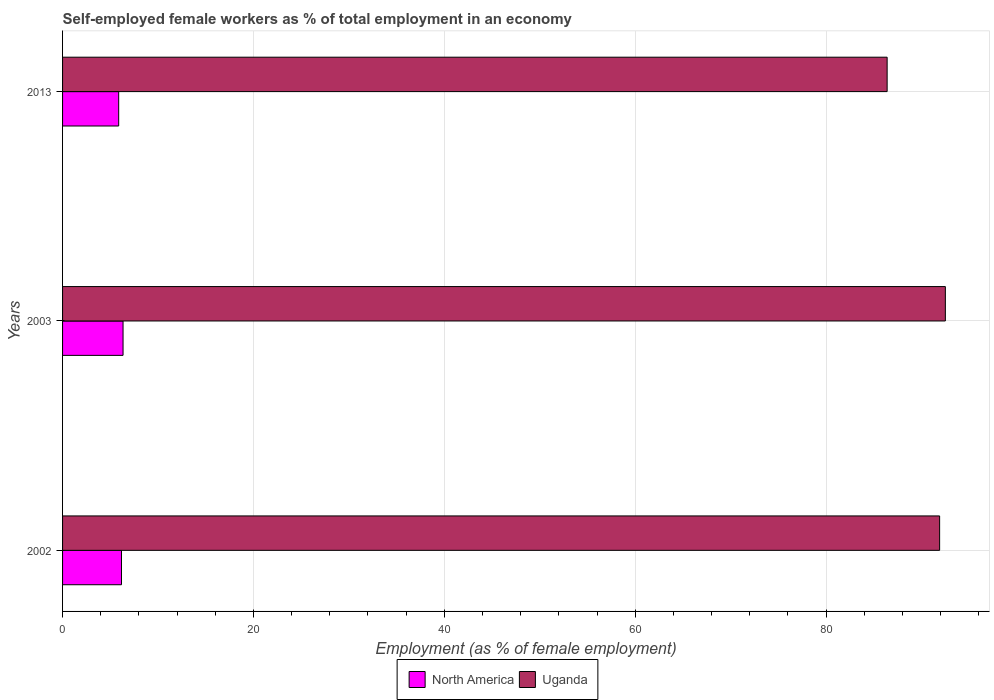Are the number of bars per tick equal to the number of legend labels?
Keep it short and to the point. Yes. How many bars are there on the 3rd tick from the top?
Your answer should be very brief. 2. How many bars are there on the 3rd tick from the bottom?
Your answer should be very brief. 2. What is the label of the 1st group of bars from the top?
Ensure brevity in your answer.  2013. What is the percentage of self-employed female workers in North America in 2002?
Make the answer very short. 6.17. Across all years, what is the maximum percentage of self-employed female workers in North America?
Give a very brief answer. 6.34. Across all years, what is the minimum percentage of self-employed female workers in North America?
Your answer should be very brief. 5.88. What is the total percentage of self-employed female workers in Uganda in the graph?
Provide a short and direct response. 270.8. What is the difference between the percentage of self-employed female workers in North America in 2003 and that in 2013?
Give a very brief answer. 0.46. What is the difference between the percentage of self-employed female workers in North America in 2013 and the percentage of self-employed female workers in Uganda in 2002?
Offer a very short reply. -86.02. What is the average percentage of self-employed female workers in North America per year?
Provide a succinct answer. 6.13. In the year 2002, what is the difference between the percentage of self-employed female workers in North America and percentage of self-employed female workers in Uganda?
Give a very brief answer. -85.73. In how many years, is the percentage of self-employed female workers in North America greater than 40 %?
Your response must be concise. 0. What is the ratio of the percentage of self-employed female workers in North America in 2003 to that in 2013?
Keep it short and to the point. 1.08. Is the difference between the percentage of self-employed female workers in North America in 2002 and 2003 greater than the difference between the percentage of self-employed female workers in Uganda in 2002 and 2003?
Your answer should be compact. Yes. What is the difference between the highest and the second highest percentage of self-employed female workers in North America?
Your response must be concise. 0.16. What is the difference between the highest and the lowest percentage of self-employed female workers in North America?
Keep it short and to the point. 0.46. In how many years, is the percentage of self-employed female workers in North America greater than the average percentage of self-employed female workers in North America taken over all years?
Offer a very short reply. 2. What does the 1st bar from the top in 2002 represents?
Your answer should be very brief. Uganda. What does the 2nd bar from the bottom in 2013 represents?
Give a very brief answer. Uganda. Are all the bars in the graph horizontal?
Provide a succinct answer. Yes. Does the graph contain grids?
Make the answer very short. Yes. How many legend labels are there?
Make the answer very short. 2. How are the legend labels stacked?
Provide a succinct answer. Horizontal. What is the title of the graph?
Provide a short and direct response. Self-employed female workers as % of total employment in an economy. What is the label or title of the X-axis?
Your answer should be very brief. Employment (as % of female employment). What is the label or title of the Y-axis?
Offer a terse response. Years. What is the Employment (as % of female employment) in North America in 2002?
Your answer should be very brief. 6.17. What is the Employment (as % of female employment) in Uganda in 2002?
Provide a short and direct response. 91.9. What is the Employment (as % of female employment) of North America in 2003?
Give a very brief answer. 6.34. What is the Employment (as % of female employment) in Uganda in 2003?
Provide a short and direct response. 92.5. What is the Employment (as % of female employment) in North America in 2013?
Your response must be concise. 5.88. What is the Employment (as % of female employment) of Uganda in 2013?
Keep it short and to the point. 86.4. Across all years, what is the maximum Employment (as % of female employment) in North America?
Give a very brief answer. 6.34. Across all years, what is the maximum Employment (as % of female employment) in Uganda?
Ensure brevity in your answer.  92.5. Across all years, what is the minimum Employment (as % of female employment) in North America?
Ensure brevity in your answer.  5.88. Across all years, what is the minimum Employment (as % of female employment) of Uganda?
Your response must be concise. 86.4. What is the total Employment (as % of female employment) in North America in the graph?
Keep it short and to the point. 18.39. What is the total Employment (as % of female employment) of Uganda in the graph?
Offer a terse response. 270.8. What is the difference between the Employment (as % of female employment) of North America in 2002 and that in 2003?
Give a very brief answer. -0.16. What is the difference between the Employment (as % of female employment) of Uganda in 2002 and that in 2003?
Keep it short and to the point. -0.6. What is the difference between the Employment (as % of female employment) in North America in 2002 and that in 2013?
Make the answer very short. 0.29. What is the difference between the Employment (as % of female employment) of Uganda in 2002 and that in 2013?
Your answer should be compact. 5.5. What is the difference between the Employment (as % of female employment) in North America in 2003 and that in 2013?
Keep it short and to the point. 0.46. What is the difference between the Employment (as % of female employment) of North America in 2002 and the Employment (as % of female employment) of Uganda in 2003?
Provide a succinct answer. -86.33. What is the difference between the Employment (as % of female employment) in North America in 2002 and the Employment (as % of female employment) in Uganda in 2013?
Provide a succinct answer. -80.23. What is the difference between the Employment (as % of female employment) of North America in 2003 and the Employment (as % of female employment) of Uganda in 2013?
Keep it short and to the point. -80.06. What is the average Employment (as % of female employment) of North America per year?
Provide a short and direct response. 6.13. What is the average Employment (as % of female employment) in Uganda per year?
Make the answer very short. 90.27. In the year 2002, what is the difference between the Employment (as % of female employment) of North America and Employment (as % of female employment) of Uganda?
Your response must be concise. -85.73. In the year 2003, what is the difference between the Employment (as % of female employment) in North America and Employment (as % of female employment) in Uganda?
Offer a terse response. -86.16. In the year 2013, what is the difference between the Employment (as % of female employment) of North America and Employment (as % of female employment) of Uganda?
Offer a very short reply. -80.52. What is the ratio of the Employment (as % of female employment) in North America in 2002 to that in 2003?
Make the answer very short. 0.97. What is the ratio of the Employment (as % of female employment) of Uganda in 2002 to that in 2003?
Provide a succinct answer. 0.99. What is the ratio of the Employment (as % of female employment) in North America in 2002 to that in 2013?
Your response must be concise. 1.05. What is the ratio of the Employment (as % of female employment) of Uganda in 2002 to that in 2013?
Provide a short and direct response. 1.06. What is the ratio of the Employment (as % of female employment) in North America in 2003 to that in 2013?
Give a very brief answer. 1.08. What is the ratio of the Employment (as % of female employment) in Uganda in 2003 to that in 2013?
Make the answer very short. 1.07. What is the difference between the highest and the second highest Employment (as % of female employment) of North America?
Provide a short and direct response. 0.16. What is the difference between the highest and the second highest Employment (as % of female employment) in Uganda?
Offer a terse response. 0.6. What is the difference between the highest and the lowest Employment (as % of female employment) of North America?
Offer a terse response. 0.46. What is the difference between the highest and the lowest Employment (as % of female employment) in Uganda?
Provide a short and direct response. 6.1. 